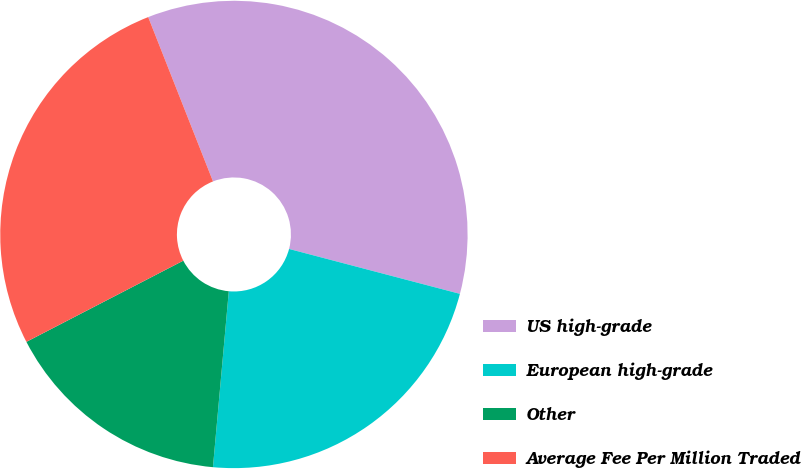<chart> <loc_0><loc_0><loc_500><loc_500><pie_chart><fcel>US high-grade<fcel>European high-grade<fcel>Other<fcel>Average Fee Per Million Traded<nl><fcel>35.07%<fcel>22.34%<fcel>15.97%<fcel>26.62%<nl></chart> 